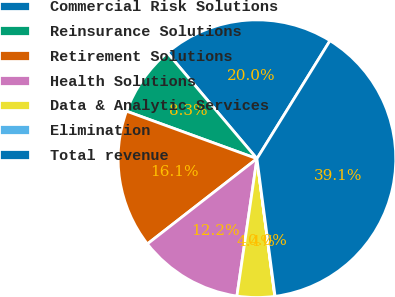Convert chart. <chart><loc_0><loc_0><loc_500><loc_500><pie_chart><fcel>Commercial Risk Solutions<fcel>Reinsurance Solutions<fcel>Retirement Solutions<fcel>Health Solutions<fcel>Data & Analytic Services<fcel>Elimination<fcel>Total revenue<nl><fcel>19.99%<fcel>8.27%<fcel>16.08%<fcel>12.17%<fcel>4.36%<fcel>0.03%<fcel>39.09%<nl></chart> 